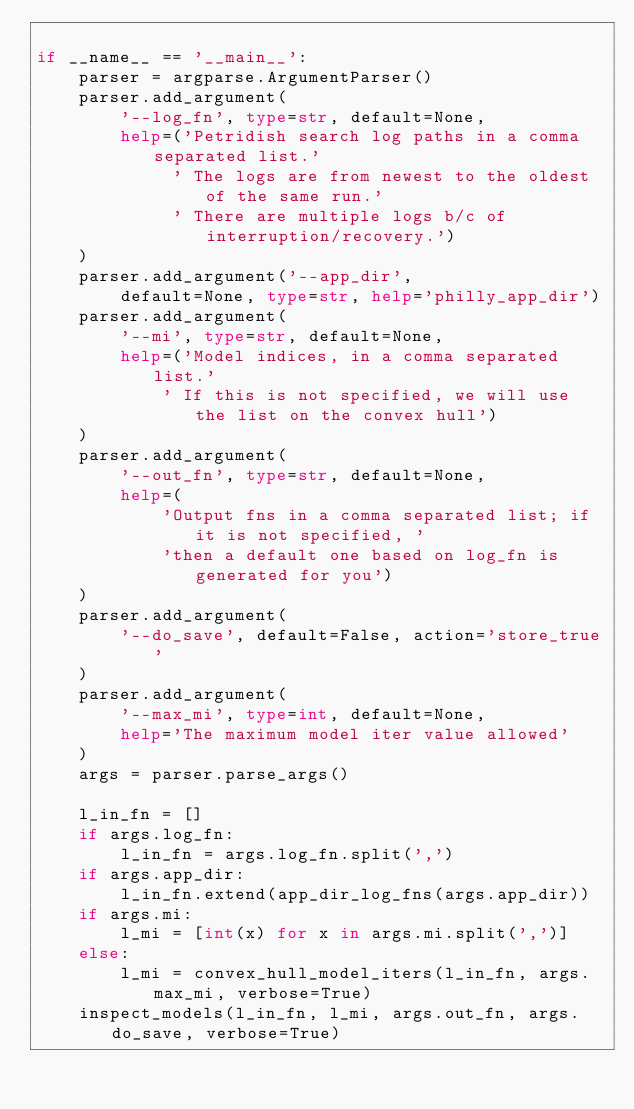Convert code to text. <code><loc_0><loc_0><loc_500><loc_500><_Python_>
if __name__ == '__main__':
    parser = argparse.ArgumentParser()
    parser.add_argument(
        '--log_fn', type=str, default=None,
        help=('Petridish search log paths in a comma separated list.'
             ' The logs are from newest to the oldest of the same run.'
             ' There are multiple logs b/c of interruption/recovery.')
    )
    parser.add_argument('--app_dir',
        default=None, type=str, help='philly_app_dir')
    parser.add_argument(
        '--mi', type=str, default=None,
        help=('Model indices, in a comma separated list.'
            ' If this is not specified, we will use the list on the convex hull')
    )
    parser.add_argument(
        '--out_fn', type=str, default=None,
        help=(
            'Output fns in a comma separated list; if it is not specified, '
            'then a default one based on log_fn is generated for you')
    )
    parser.add_argument(
        '--do_save', default=False, action='store_true'
    )
    parser.add_argument(
        '--max_mi', type=int, default=None,
        help='The maximum model iter value allowed'
    )
    args = parser.parse_args()

    l_in_fn = []
    if args.log_fn:
        l_in_fn = args.log_fn.split(',')
    if args.app_dir:
        l_in_fn.extend(app_dir_log_fns(args.app_dir))
    if args.mi:
        l_mi = [int(x) for x in args.mi.split(',')]
    else:
        l_mi = convex_hull_model_iters(l_in_fn, args.max_mi, verbose=True)
    inspect_models(l_in_fn, l_mi, args.out_fn, args.do_save, verbose=True)

</code> 